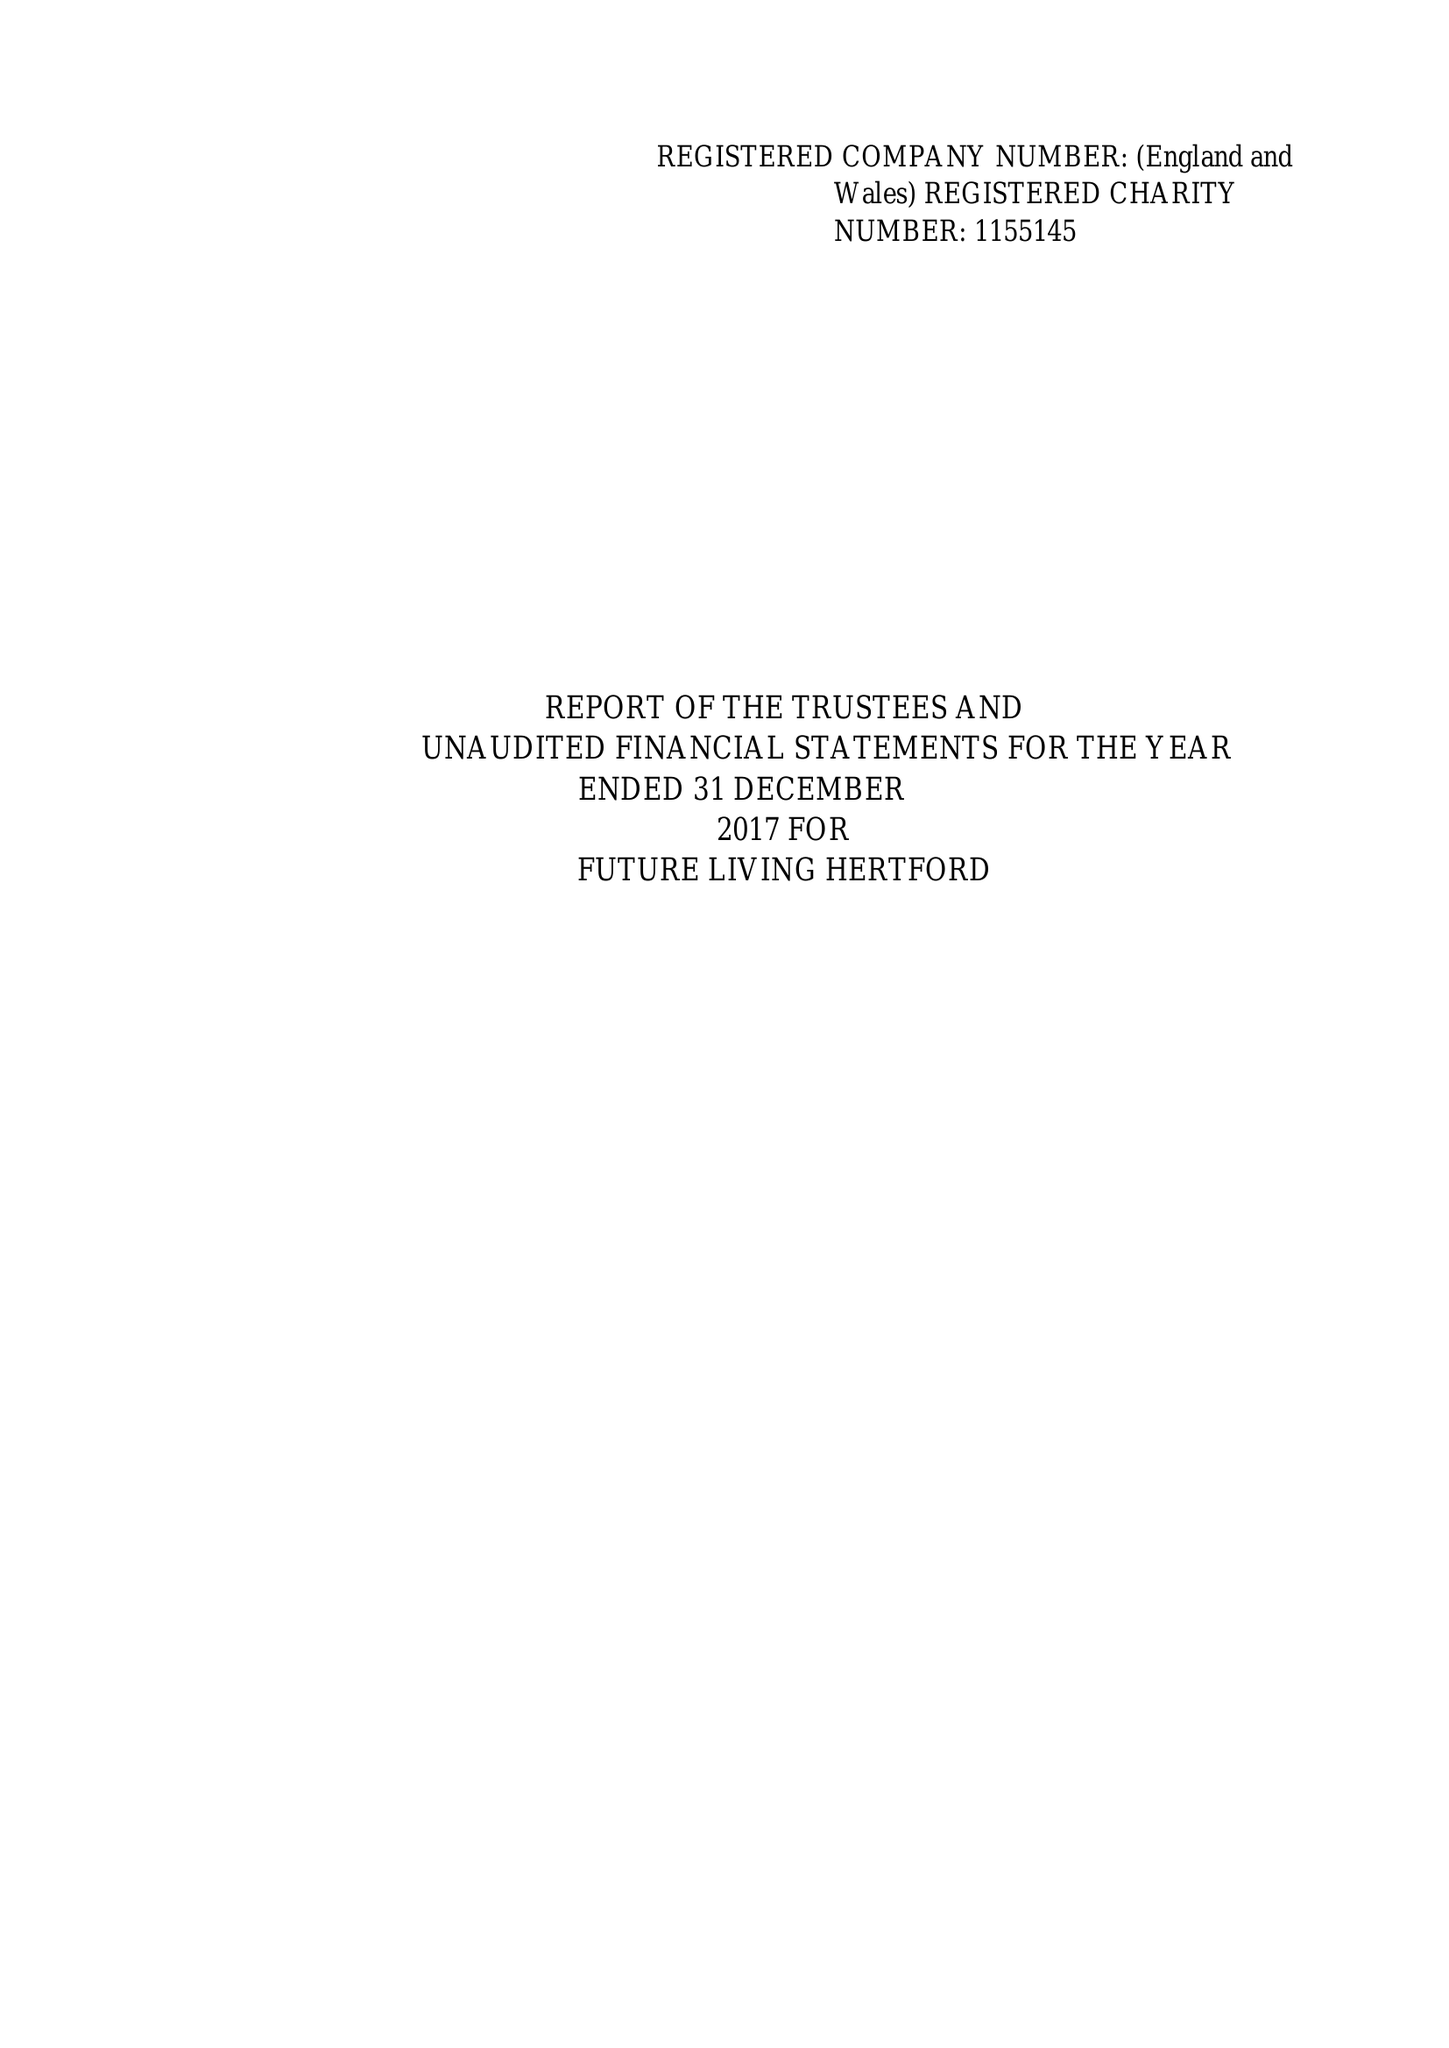What is the value for the address__post_town?
Answer the question using a single word or phrase. HERTFORD 